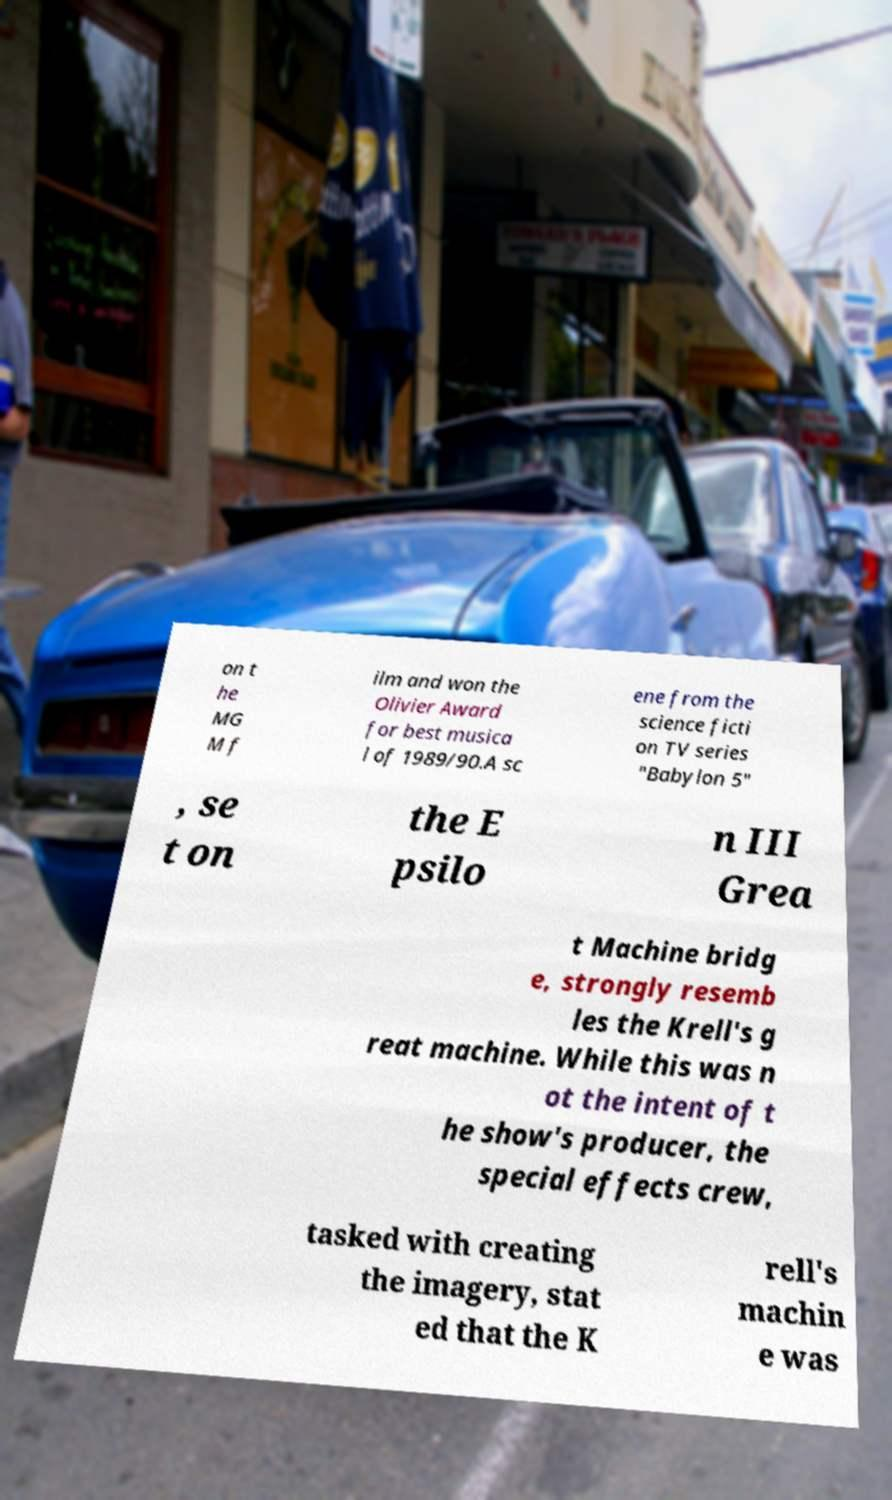There's text embedded in this image that I need extracted. Can you transcribe it verbatim? on t he MG M f ilm and won the Olivier Award for best musica l of 1989/90.A sc ene from the science ficti on TV series "Babylon 5" , se t on the E psilo n III Grea t Machine bridg e, strongly resemb les the Krell's g reat machine. While this was n ot the intent of t he show's producer, the special effects crew, tasked with creating the imagery, stat ed that the K rell's machin e was 